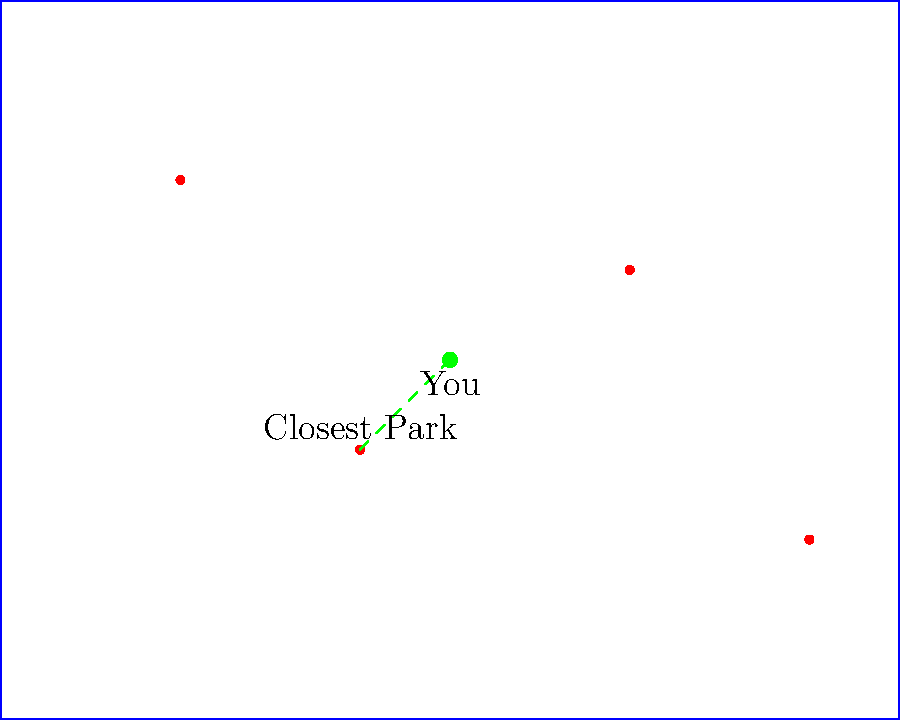Based on the simplified map of Pennsylvania state parks shown, which park is closest to your location, and approximately how far is it in miles if the map scale is 1 unit = 2 miles? To solve this problem, we'll follow these steps:

1. Identify your location on the map (green dot).
2. Locate all state parks (red dots).
3. Calculate the distance between your location and each park.
4. Determine the shortest distance.
5. Convert the distance to miles using the given scale.

Let's go through each step:

1. Your location is at coordinates (50, 40).

2. The state parks are located at:
   Park 1: (20, 60)
   Park 2: (40, 30)
   Park 3: (70, 50)
   Park 4: (90, 20)

3. Calculate distances using the distance formula: $d = \sqrt{(x_2-x_1)^2 + (y_2-y_1)^2}$

   Park 1: $d_1 = \sqrt{(20-50)^2 + (60-40)^2} = \sqrt{900 + 400} = \sqrt{1300} \approx 36.06$
   Park 2: $d_2 = \sqrt{(40-50)^2 + (30-40)^2} = \sqrt{100 + 100} = \sqrt{200} \approx 14.14$
   Park 3: $d_3 = \sqrt{(70-50)^2 + (50-40)^2} = \sqrt{400 + 100} = \sqrt{500} \approx 22.36$
   Park 4: $d_4 = \sqrt{(90-50)^2 + (20-40)^2} = \sqrt{1600 + 400} = \sqrt{2000} \approx 44.72$

4. The shortest distance is to Park 2, approximately 14.14 units.

5. Convert to miles: 14.14 units * 2 miles/unit ≈ 28.28 miles

The closest park is the one directly south of your location (Park 2), and it's approximately 28 miles away.
Answer: Park 2, ~28 miles 